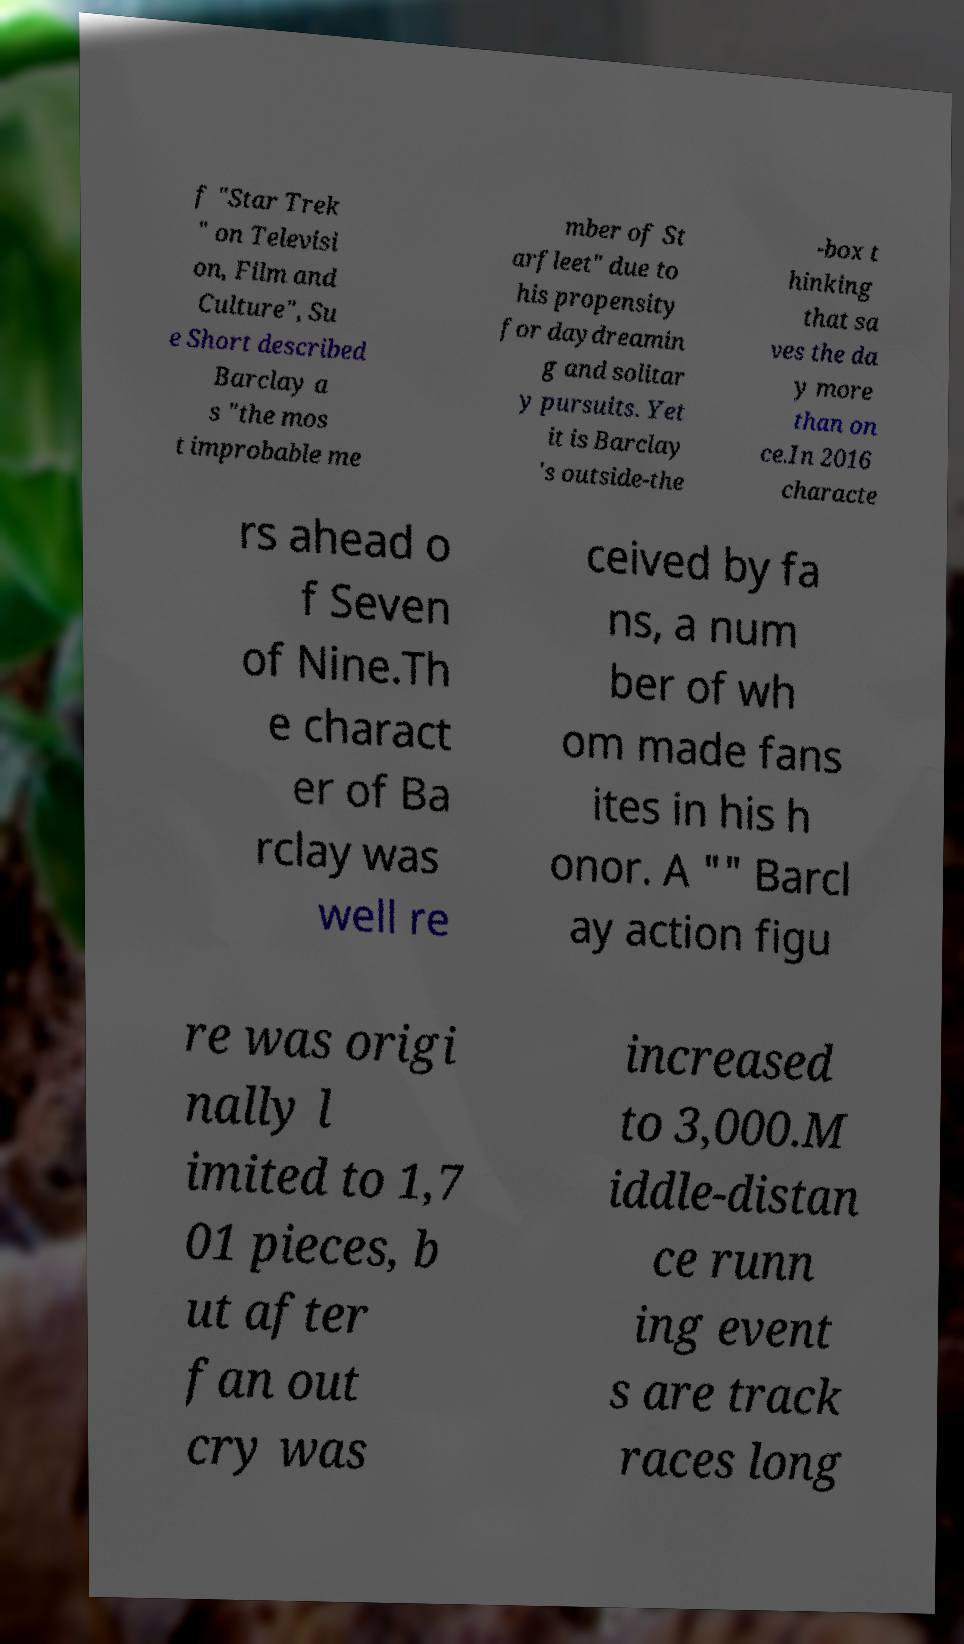Can you read and provide the text displayed in the image?This photo seems to have some interesting text. Can you extract and type it out for me? f "Star Trek " on Televisi on, Film and Culture", Su e Short described Barclay a s "the mos t improbable me mber of St arfleet" due to his propensity for daydreamin g and solitar y pursuits. Yet it is Barclay 's outside-the -box t hinking that sa ves the da y more than on ce.In 2016 characte rs ahead o f Seven of Nine.Th e charact er of Ba rclay was well re ceived by fa ns, a num ber of wh om made fans ites in his h onor. A "" Barcl ay action figu re was origi nally l imited to 1,7 01 pieces, b ut after fan out cry was increased to 3,000.M iddle-distan ce runn ing event s are track races long 